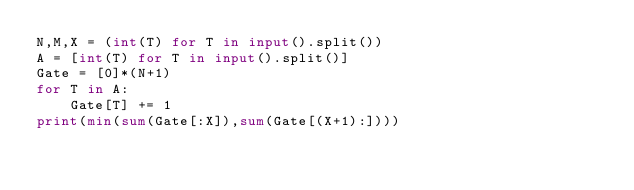<code> <loc_0><loc_0><loc_500><loc_500><_Python_>N,M,X = (int(T) for T in input().split())
A = [int(T) for T in input().split()]
Gate = [0]*(N+1)
for T in A:
    Gate[T] += 1
print(min(sum(Gate[:X]),sum(Gate[(X+1):])))</code> 